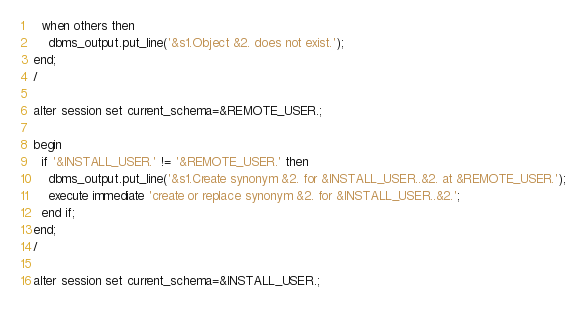<code> <loc_0><loc_0><loc_500><loc_500><_SQL_>  when others then
    dbms_output.put_line('&s1.Object &2. does not exist.');
end;
/

alter session set current_schema=&REMOTE_USER.;

begin
  if '&INSTALL_USER.' != '&REMOTE_USER.' then
    dbms_output.put_line('&s1.Create synonym &2. for &INSTALL_USER..&2. at &REMOTE_USER.');
    execute immediate 'create or replace synonym &2. for &INSTALL_USER..&2.';
  end if;
end;
/

alter session set current_schema=&INSTALL_USER.;</code> 